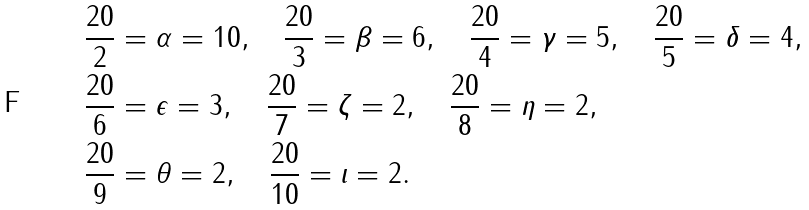Convert formula to latex. <formula><loc_0><loc_0><loc_500><loc_500>& \frac { 2 0 } { 2 } = \alpha = 1 0 , \quad \frac { 2 0 } { 3 } = \beta = 6 , \quad \frac { 2 0 } { 4 } = \gamma = 5 , \quad \frac { 2 0 } { 5 } = \delta = 4 , \\ & \frac { 2 0 } { 6 } = \epsilon = 3 , \quad \frac { 2 0 } { 7 } = \zeta = 2 , \quad \frac { 2 0 } { 8 } = \eta = 2 , \\ & \frac { 2 0 } { 9 } = \theta = 2 , \quad \frac { 2 0 } { 1 0 } = \iota = 2 .</formula> 